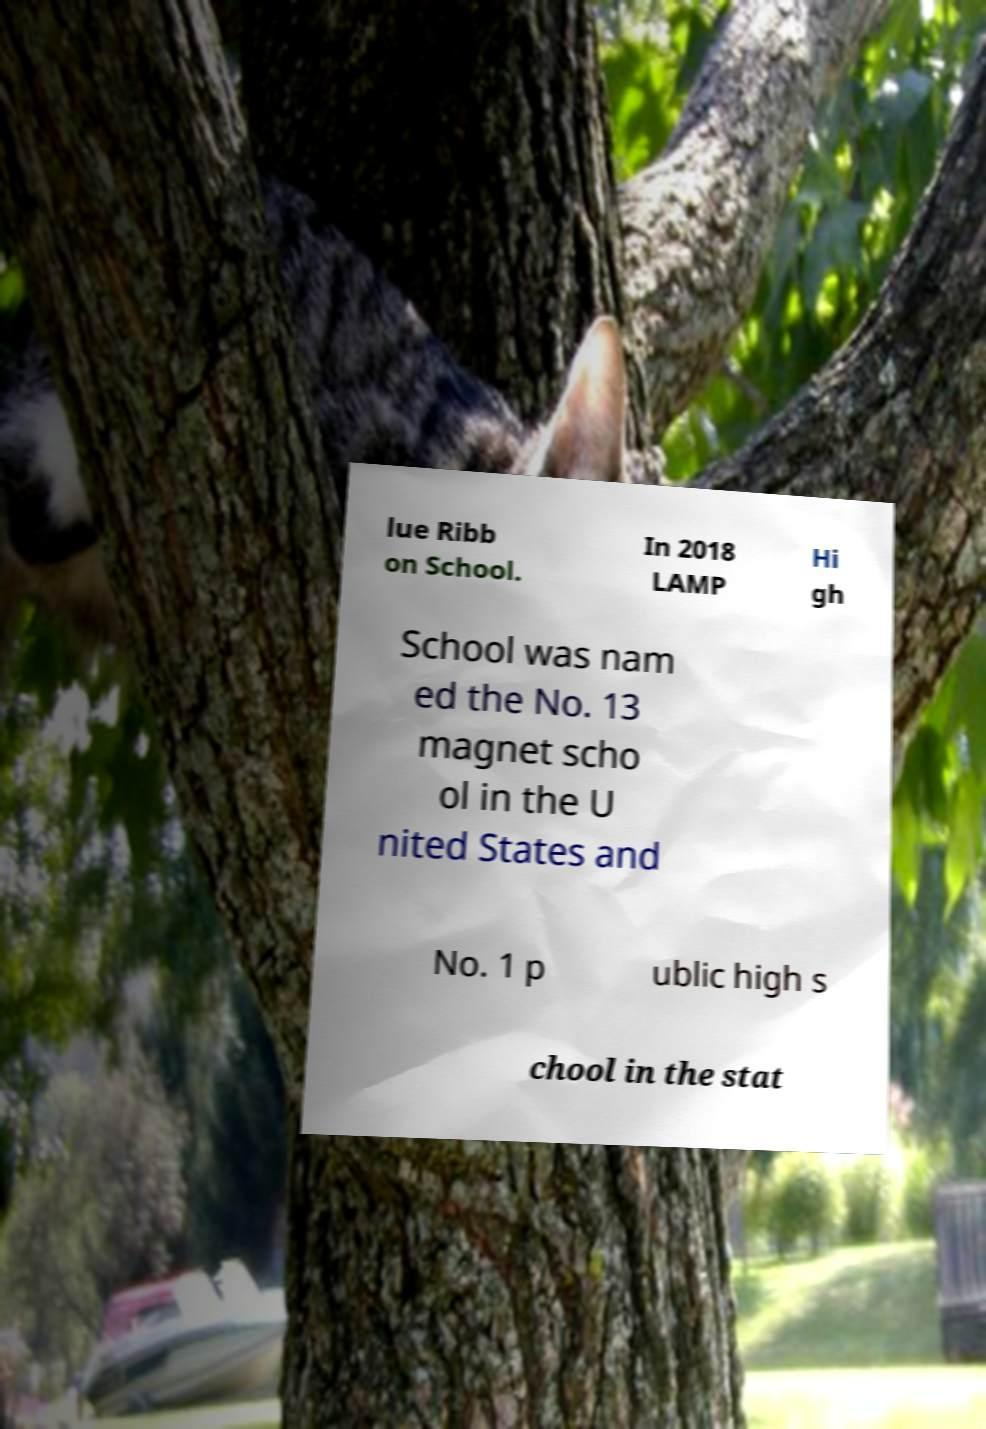I need the written content from this picture converted into text. Can you do that? lue Ribb on School. In 2018 LAMP Hi gh School was nam ed the No. 13 magnet scho ol in the U nited States and No. 1 p ublic high s chool in the stat 